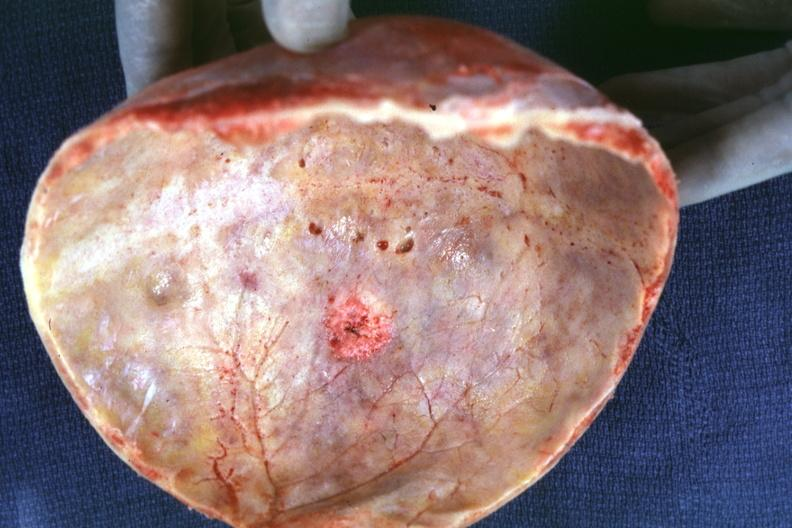where does this image show skull cap with obvious metastatic lesion seen on?
Answer the question using a single word or phrase. Inner table prostate primary 